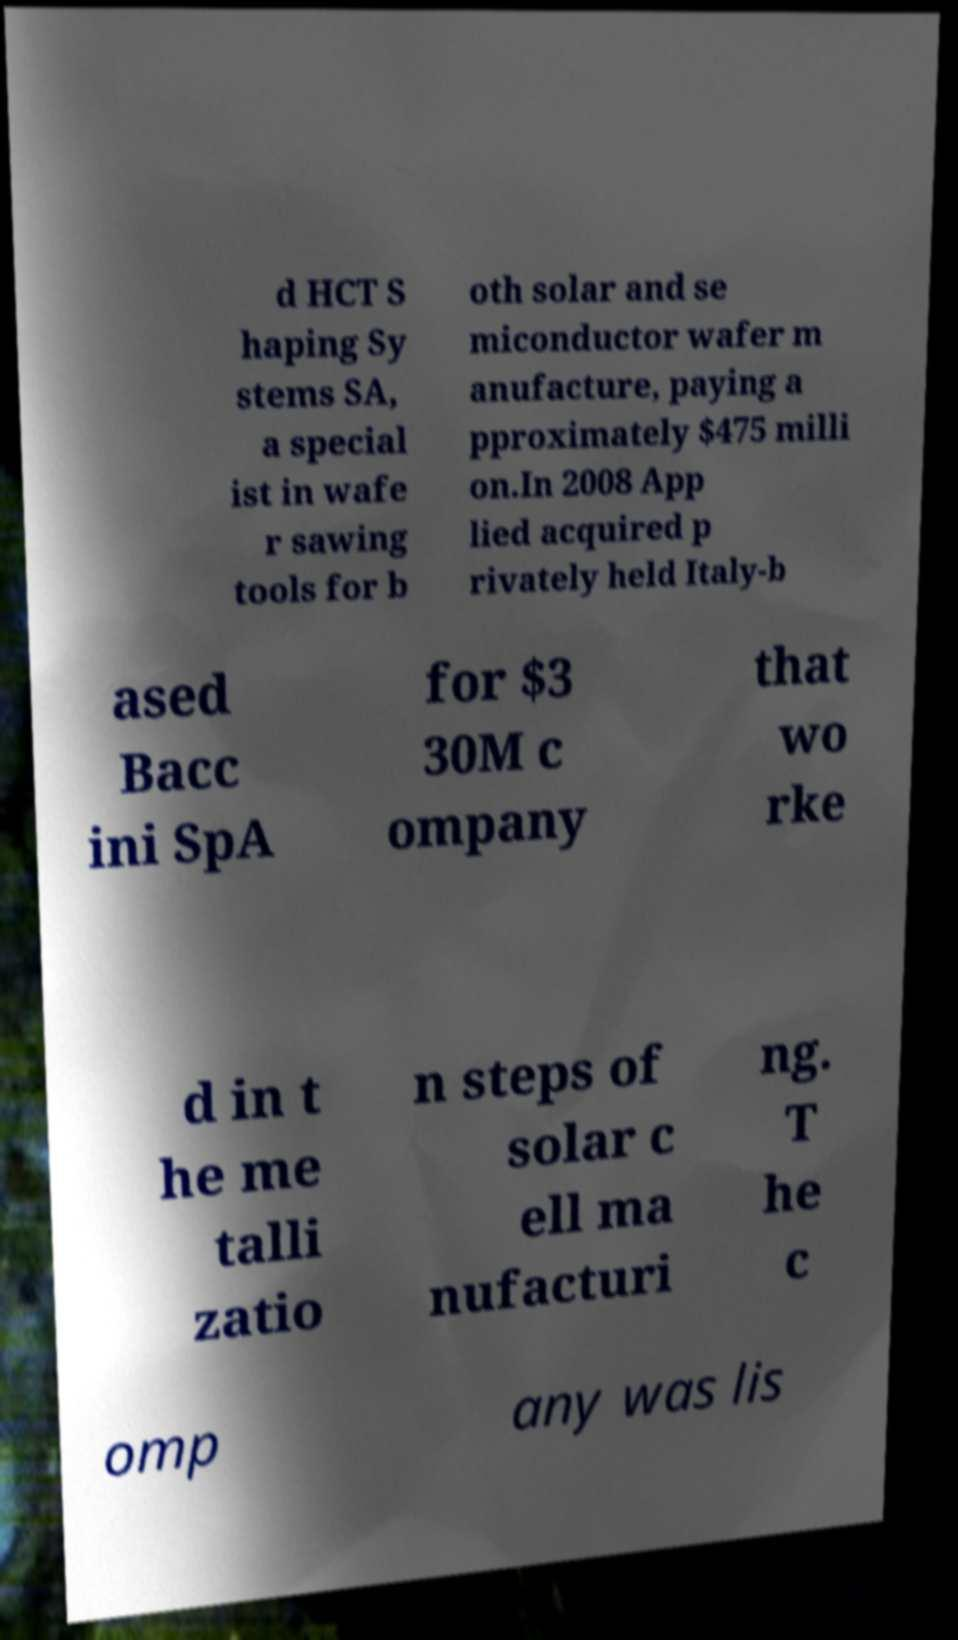For documentation purposes, I need the text within this image transcribed. Could you provide that? d HCT S haping Sy stems SA, a special ist in wafe r sawing tools for b oth solar and se miconductor wafer m anufacture, paying a pproximately $475 milli on.In 2008 App lied acquired p rivately held Italy-b ased Bacc ini SpA for $3 30M c ompany that wo rke d in t he me talli zatio n steps of solar c ell ma nufacturi ng. T he c omp any was lis 